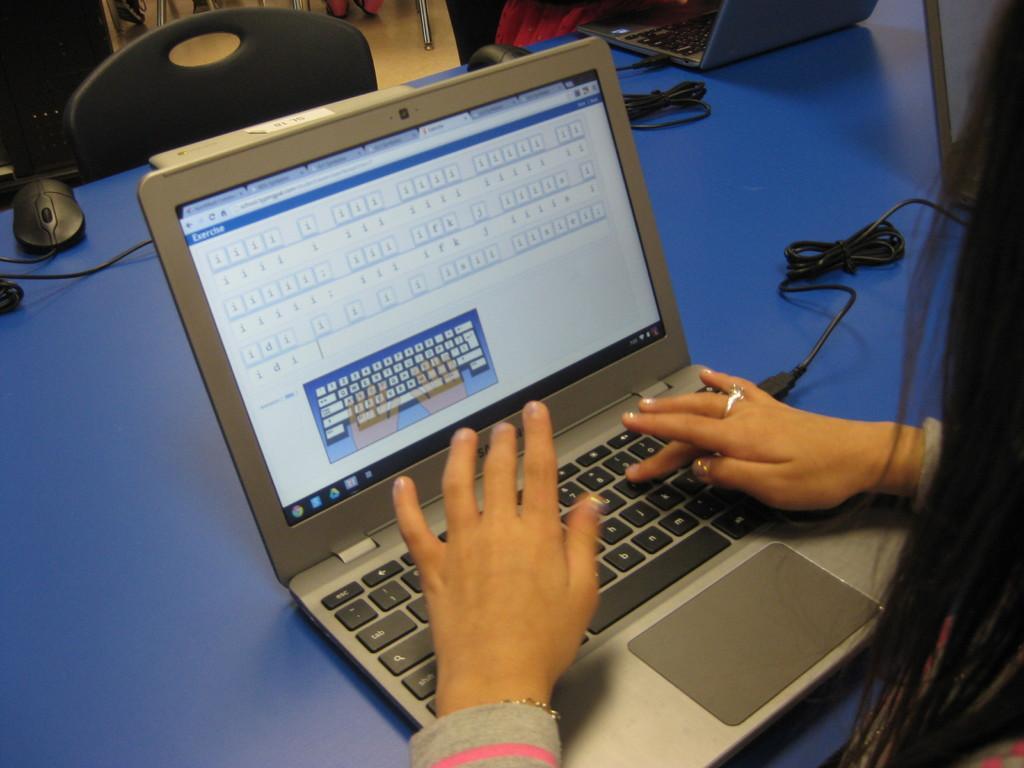How would you summarize this image in a sentence or two? In this picture I can see there is a woman sitting here and she is operating a laptop and there is a table in front of her and there are many other people standing here in the backdrop and there are cables connected to the laptop. 